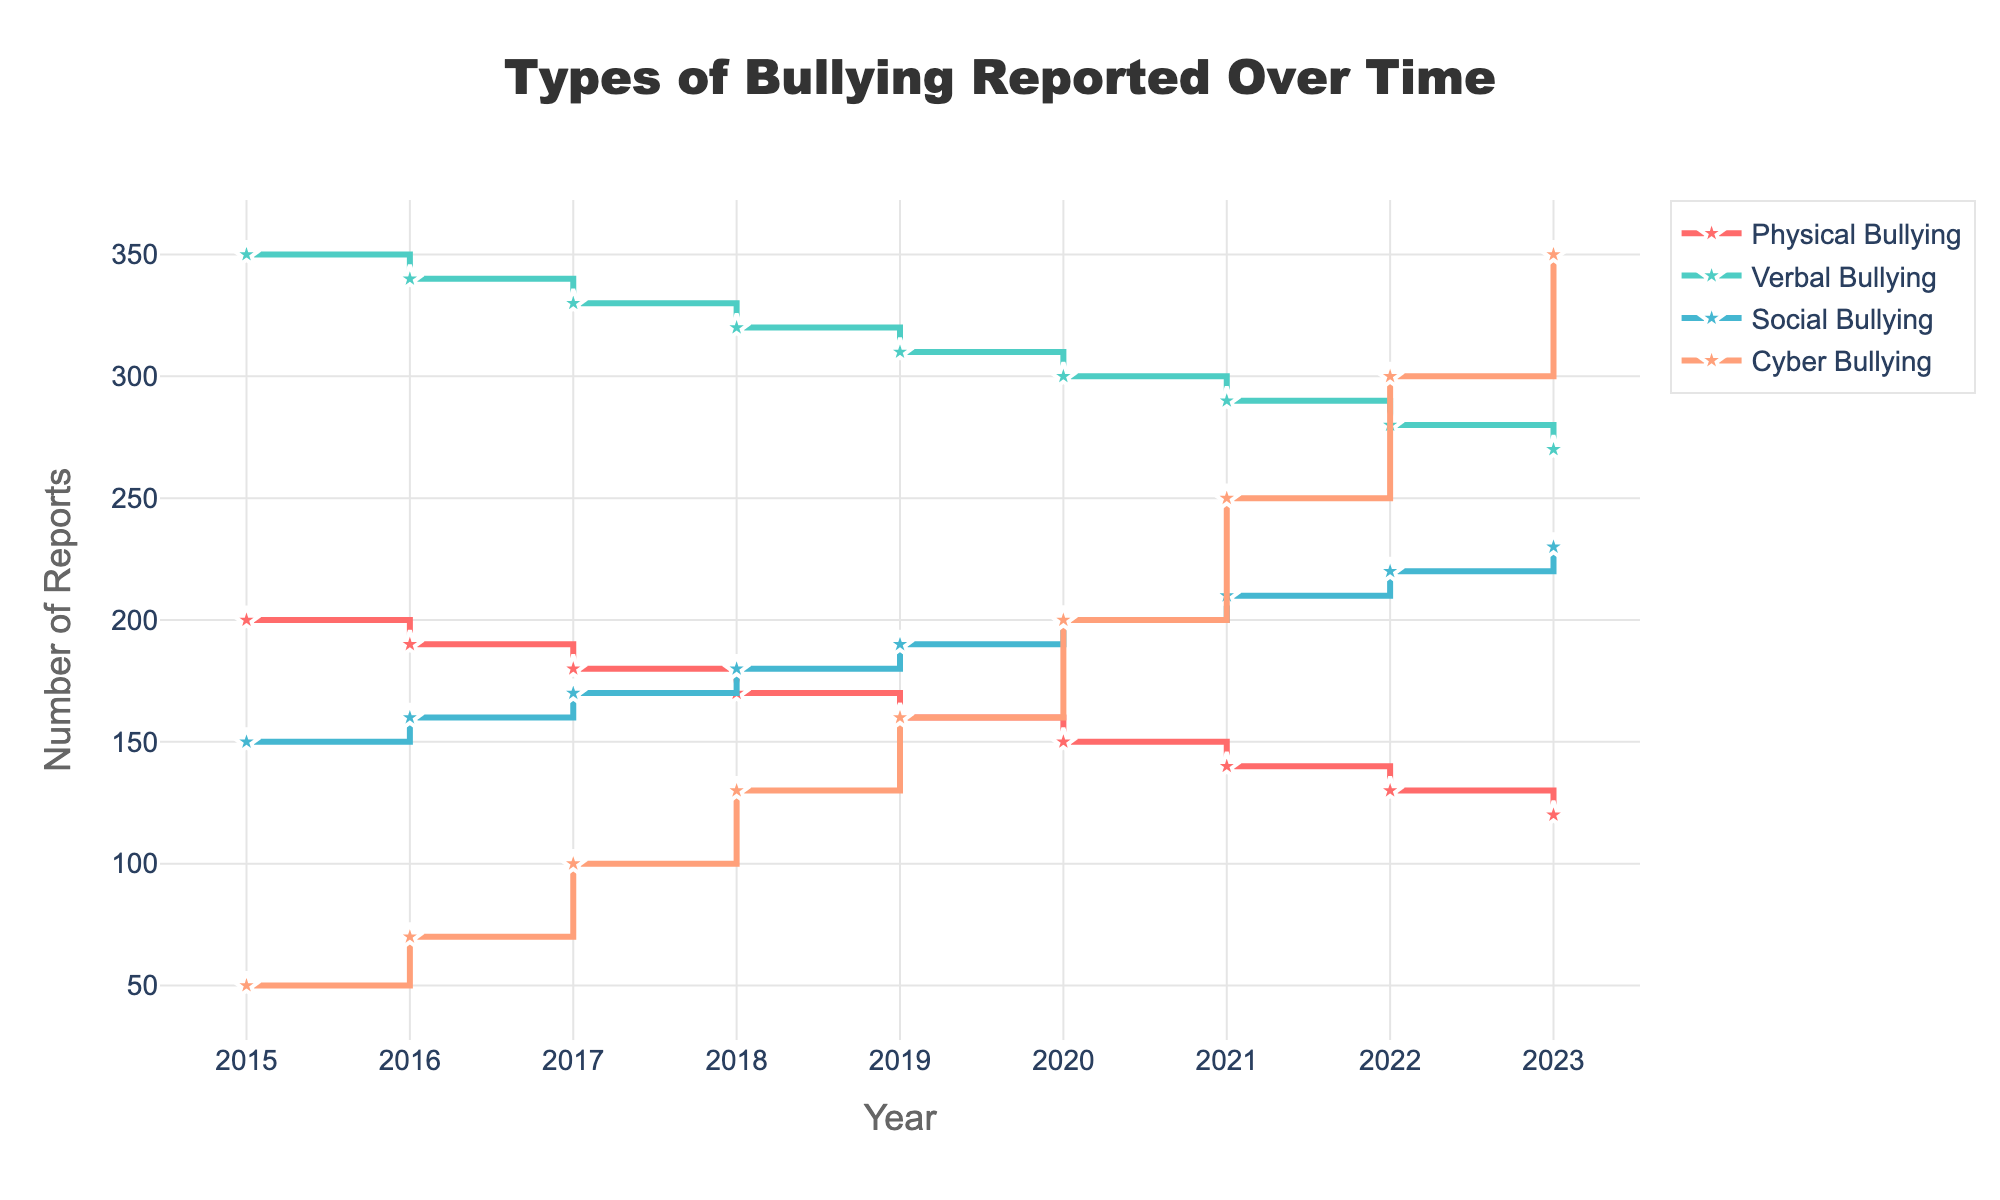What is the title of the plot? The title is located at the top center of the figure and reads "Types of Bullying Reported Over Time".
Answer: Types of Bullying Reported Over Time What is the general trend of Physical Bullying from 2015 to 2023? By looking at the stair step lines for Physical Bullying, we can see a continuous decrease in the number of reported cases from 200 in 2015 to 120 in 2023.
Answer: Decreasing How many types of bullying are reported in the plot? The legend on the right side of the plot shows the names of the types of bullying. There are four distinct types: Physical Bullying, Verbal Bullying, Social Bullying, and Cyber Bullying.
Answer: Four Compare the number of Cyber Bullying reports in 2018 and 2023. How did it change? The number of Cyber Bullying reports is marked at 130 in 2018 and increases to 350 in 2023. The change is calculated as 350 - 130.
Answer: Increased by 220 Between which years did Social Bullying report the highest annual increase? By looking at the plot for Social Bullying, the largest annual increment appears between 2022 (220) and 2023 (230). This is an increase of 10.
Answer: 2022 to 2023 What is the value for Verbal Bullying in 2020? The plot shows the stair step line for Verbal Bullying aligns with the y-axis value of 300 in the year 2020.
Answer: 300 Which type of bullying had the most reported cases in 2019? According to the legend and observing the lines at the year 2019, Verbal Bullying line is the highest, falling at 310.
Answer: Verbal Bullying What is the total number of bullying reports for 2017 combining all types? The values of different types of bullying in 2017 are 180 (Physical) + 330 (Verbal) + 170 (Social) + 100 (Cyber). Summing these gives 780.
Answer: 780 Describe the pattern or shape of the line for Cyber Bullying. Cyber Bullying shows a sharp and steady increase over the period from 2015 to 2023, represented by a consistently upward staircase shape in cyan color.
Answer: Steadily increasing Which type of bullying shows consistent decline over the years? By examining the lines for all types, Physical Bullying demonstrates a clear and consistent decline from 2015 to 2023.
Answer: Physical Bullying 